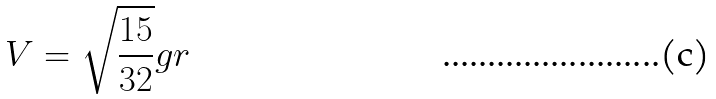<formula> <loc_0><loc_0><loc_500><loc_500>V = \sqrt { \frac { 1 5 } { 3 2 } } g r</formula> 